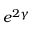Convert formula to latex. <formula><loc_0><loc_0><loc_500><loc_500>e ^ { 2 \gamma }</formula> 